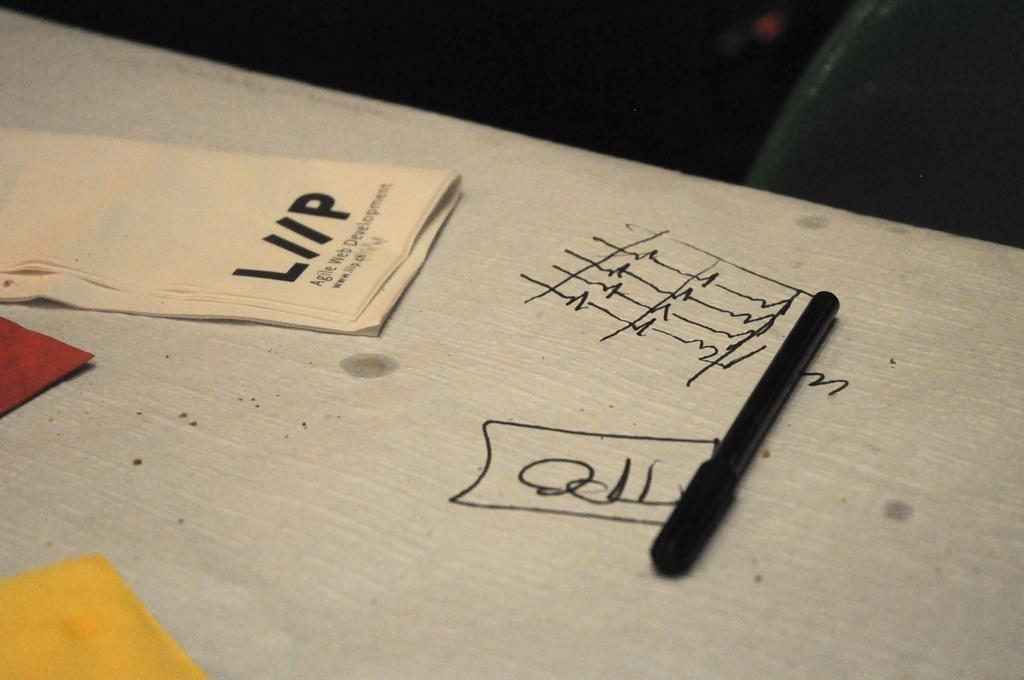What piece of furniture is present in the image? There is a table in the image. What object can be seen on the table? There is a pen on the table. What else is on the table besides the pen? There are clothes on the table. What can be read or seen written on the table? There is text visible on the table. Where is the shelf located in the image? There is no shelf present in the image. How many divisions can be seen on the table in the image? The image does not show any divisions on the table. 